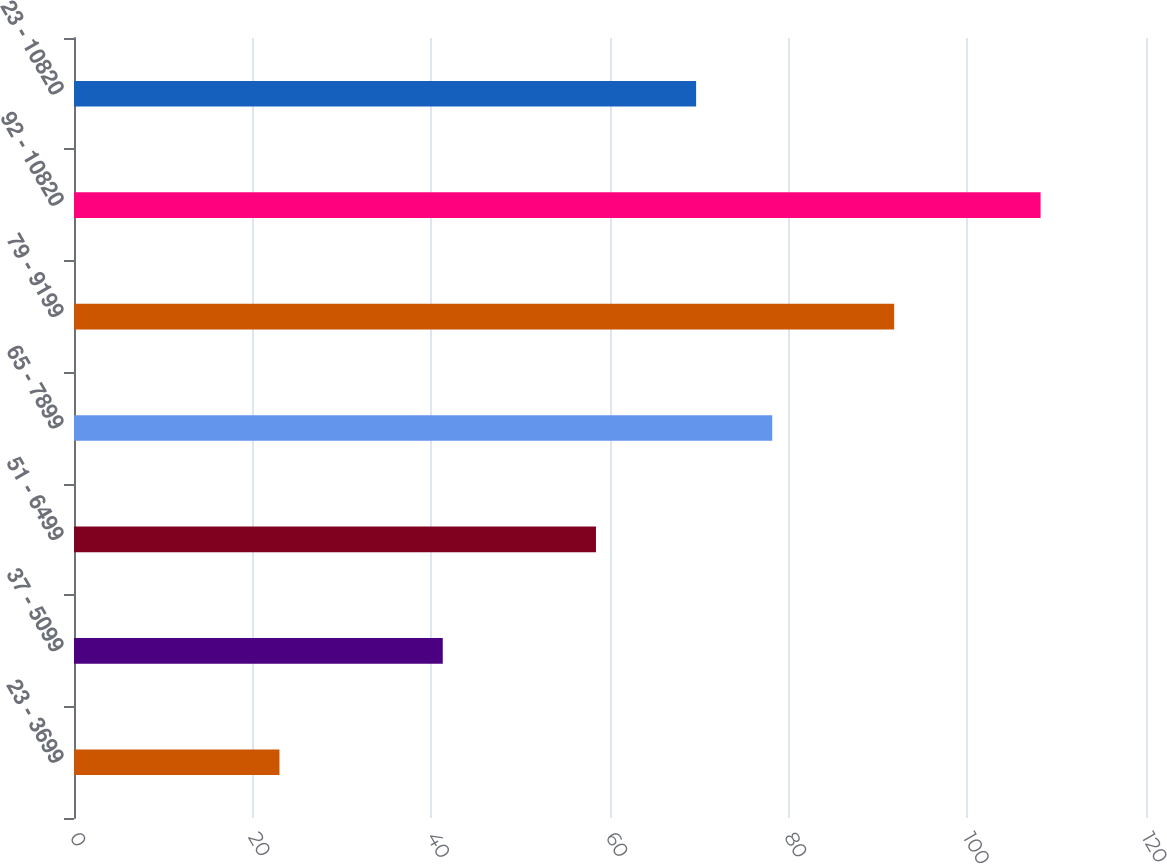Convert chart. <chart><loc_0><loc_0><loc_500><loc_500><bar_chart><fcel>23 - 3699<fcel>37 - 5099<fcel>51 - 6499<fcel>65 - 7899<fcel>79 - 9199<fcel>92 - 10820<fcel>23 - 10820<nl><fcel>23<fcel>41.28<fcel>58.43<fcel>78.16<fcel>91.81<fcel>108.2<fcel>69.64<nl></chart> 